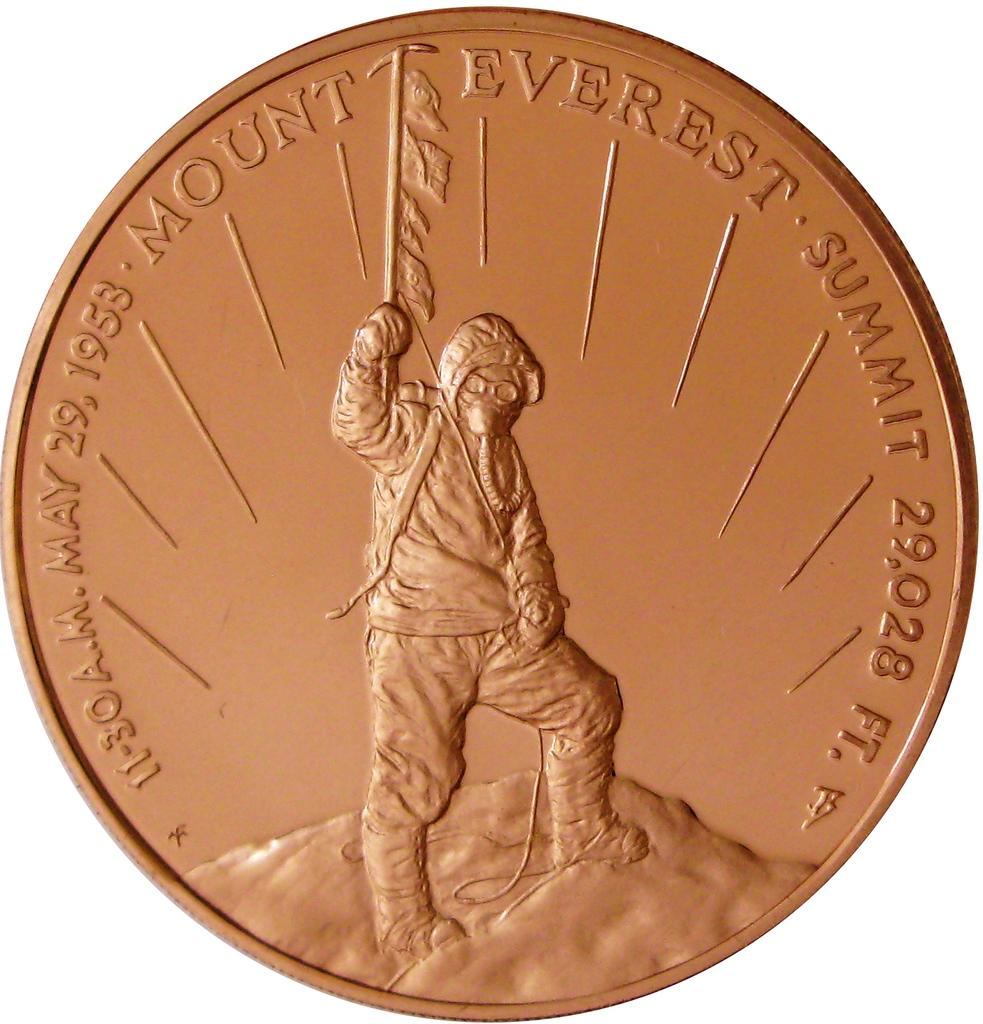What object can be seen in the image that has a copper color? There is a coin in the image, and it is in copper color. Can you describe the man standing in the image? Unfortunately, the provided facts do not give any information about the man's appearance or actions. What is the primary subject of the image? The primary subject of the image is the copper-colored coin. What type of base is supporting the crib in the image? There is no crib present in the image, so it is not possible to answer that question. 